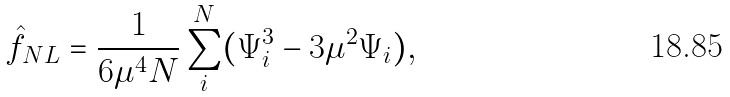Convert formula to latex. <formula><loc_0><loc_0><loc_500><loc_500>\hat { f } _ { N L } = \frac { 1 } { 6 \mu ^ { 4 } N } \sum _ { i } ^ { N } ( \Psi _ { i } ^ { 3 } - 3 \mu ^ { 2 } \Psi _ { i } ) ,</formula> 